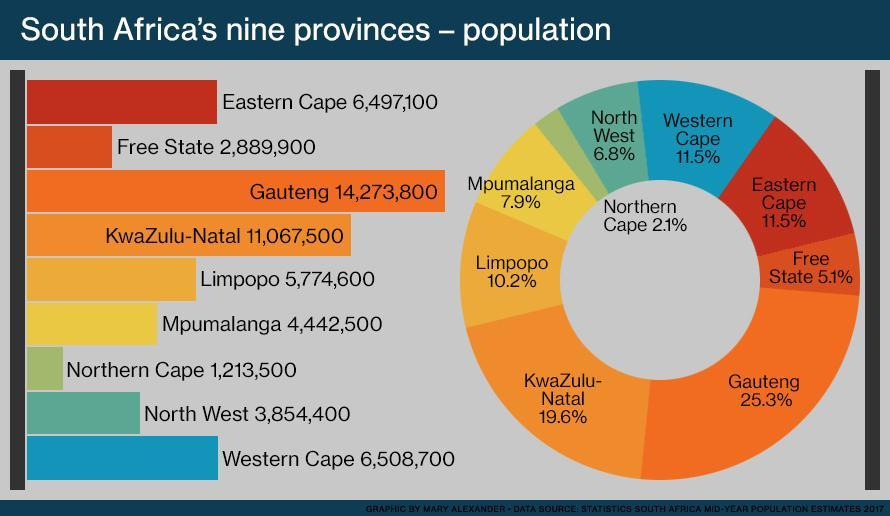What is the percentage of the population in Free State and Eastern Cape, taken together?
Answer the question with a short phrase. 16.6% What is the percentage of the population in North West and Western Cape, taken together? 18.3% What is the percentage of the population in Limpopo and Mpumalanga, taken together? 18.1% What is the percentage of the population in Gauteng and KwaZulu-Natal, taken together? 44.9% What is the percentage of the population in the Northern Cape and Western Cape, taken together? 13.6% 